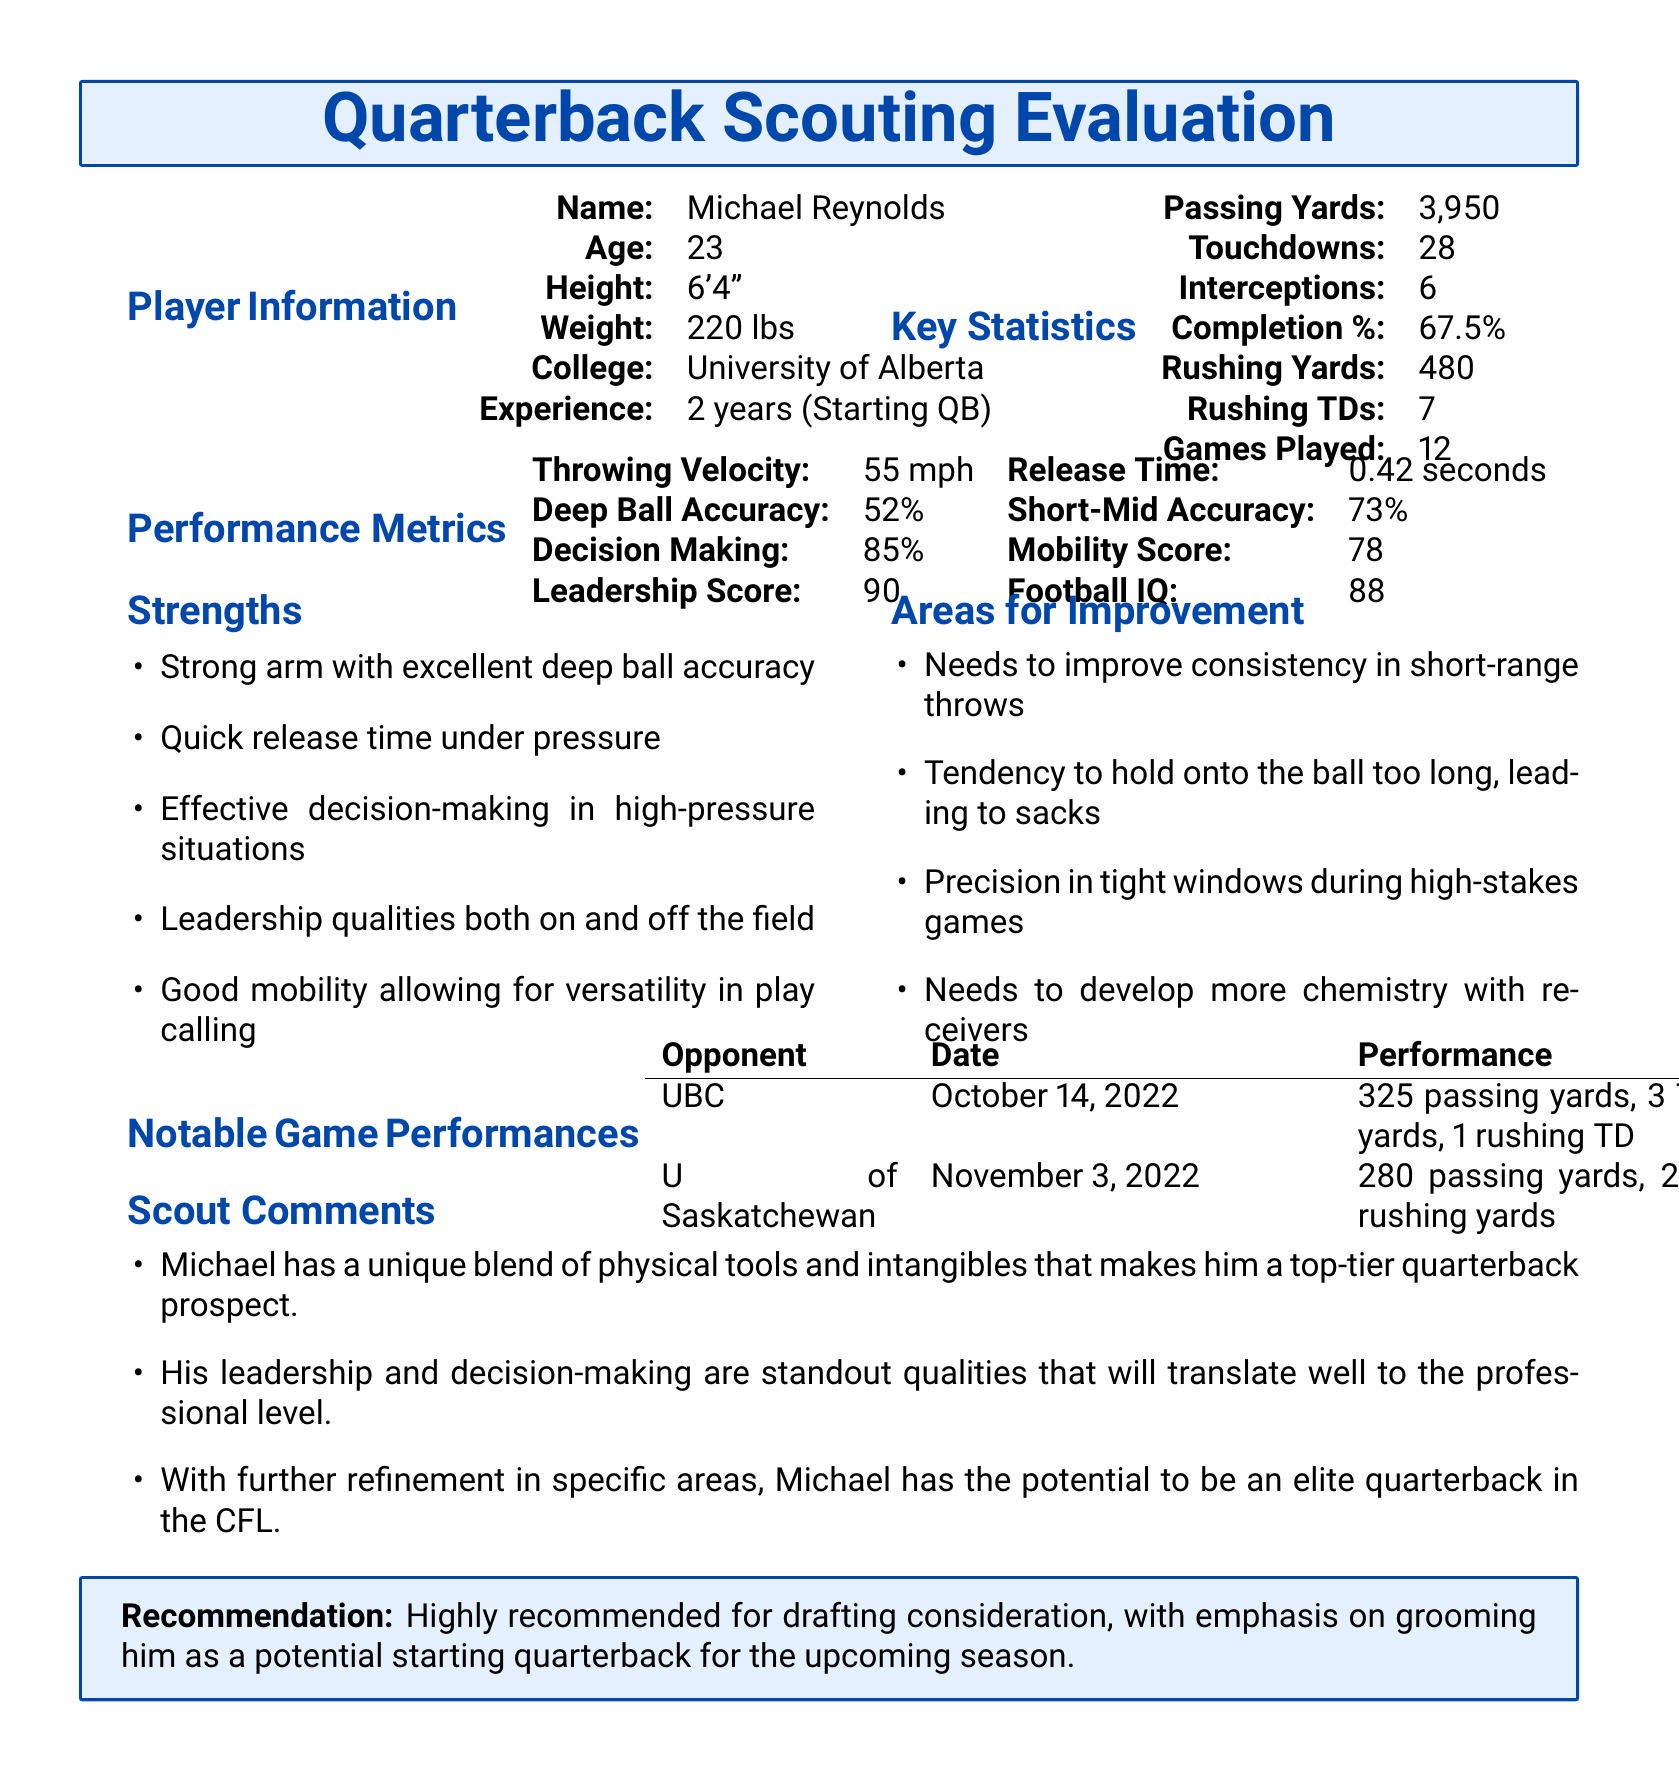What is the name of the player? The player's name is listed prominently under Player Information, which is Michael Reynolds.
Answer: Michael Reynolds What is the player's completion percentage? The completion percentage is stated under Key Statistics, which reads 67.5%.
Answer: 67.5% How many touchdowns did the player throw? The number of touchdowns thrown is provided under Key Statistics, indicating 28 touchdowns.
Answer: 28 What is the player's rushing yards? Rushing yards are found in the Key Statistics section, showing a total of 480 rushing yards.
Answer: 480 What is the player's leadership score? The leadership score is part of the Performance Metrics section, which indicates a score of 90.
Answer: 90 Which college did the player attend? The player's college is provided in the Player Information section, indicating he attended the University of Alberta.
Answer: University of Alberta What are the notable game performances against UBC? The notable game performance includes specific stats found in the Notable Game Performances section against UBC, detailing 325 passing yards and 3 touchdowns.
Answer: 325 passing yards, 3 TDs What are the key strengths of the player? The strengths the player possesses are listed in their respective section, focusing on arm strength, quick release, and effective decision-making.
Answer: Strong arm with excellent deep ball accuracy What is the recommendation for the player? The recommendation is stated in a summarized box at the end of the document, highlighting the drafting consideration of the player.
Answer: Highly recommended for drafting consideration 